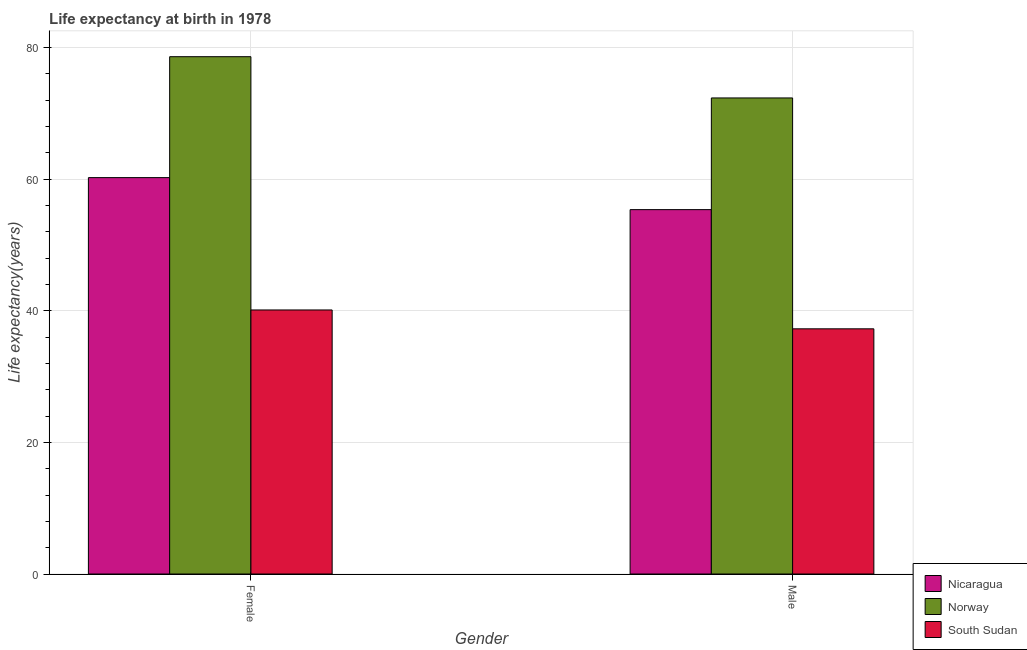How many different coloured bars are there?
Make the answer very short. 3. How many bars are there on the 2nd tick from the left?
Keep it short and to the point. 3. How many bars are there on the 1st tick from the right?
Your response must be concise. 3. What is the life expectancy(female) in South Sudan?
Make the answer very short. 40.13. Across all countries, what is the maximum life expectancy(female)?
Keep it short and to the point. 78.63. Across all countries, what is the minimum life expectancy(male)?
Keep it short and to the point. 37.27. In which country was the life expectancy(female) maximum?
Your answer should be compact. Norway. In which country was the life expectancy(male) minimum?
Your answer should be compact. South Sudan. What is the total life expectancy(female) in the graph?
Offer a terse response. 179.01. What is the difference between the life expectancy(female) in Norway and that in South Sudan?
Your answer should be very brief. 38.5. What is the difference between the life expectancy(female) in Nicaragua and the life expectancy(male) in Norway?
Your answer should be very brief. -12.11. What is the average life expectancy(male) per country?
Give a very brief answer. 55. What is the difference between the life expectancy(female) and life expectancy(male) in South Sudan?
Offer a terse response. 2.87. In how many countries, is the life expectancy(male) greater than 40 years?
Offer a terse response. 2. What is the ratio of the life expectancy(male) in South Sudan to that in Nicaragua?
Provide a succinct answer. 0.67. Is the life expectancy(male) in Nicaragua less than that in Norway?
Give a very brief answer. Yes. What does the 1st bar from the left in Male represents?
Your answer should be very brief. Nicaragua. What does the 3rd bar from the right in Male represents?
Keep it short and to the point. Nicaragua. How many bars are there?
Your response must be concise. 6. How many countries are there in the graph?
Make the answer very short. 3. What is the difference between two consecutive major ticks on the Y-axis?
Your answer should be compact. 20. Does the graph contain grids?
Ensure brevity in your answer.  Yes. What is the title of the graph?
Your answer should be compact. Life expectancy at birth in 1978. Does "Czech Republic" appear as one of the legend labels in the graph?
Your answer should be very brief. No. What is the label or title of the X-axis?
Your answer should be compact. Gender. What is the label or title of the Y-axis?
Make the answer very short. Life expectancy(years). What is the Life expectancy(years) in Nicaragua in Female?
Offer a very short reply. 60.25. What is the Life expectancy(years) in Norway in Female?
Ensure brevity in your answer.  78.63. What is the Life expectancy(years) of South Sudan in Female?
Your response must be concise. 40.13. What is the Life expectancy(years) of Nicaragua in Male?
Your answer should be very brief. 55.38. What is the Life expectancy(years) in Norway in Male?
Offer a terse response. 72.36. What is the Life expectancy(years) in South Sudan in Male?
Your response must be concise. 37.27. Across all Gender, what is the maximum Life expectancy(years) in Nicaragua?
Your answer should be very brief. 60.25. Across all Gender, what is the maximum Life expectancy(years) in Norway?
Make the answer very short. 78.63. Across all Gender, what is the maximum Life expectancy(years) in South Sudan?
Give a very brief answer. 40.13. Across all Gender, what is the minimum Life expectancy(years) in Nicaragua?
Keep it short and to the point. 55.38. Across all Gender, what is the minimum Life expectancy(years) of Norway?
Keep it short and to the point. 72.36. Across all Gender, what is the minimum Life expectancy(years) in South Sudan?
Keep it short and to the point. 37.27. What is the total Life expectancy(years) in Nicaragua in the graph?
Give a very brief answer. 115.63. What is the total Life expectancy(years) in Norway in the graph?
Keep it short and to the point. 150.99. What is the total Life expectancy(years) of South Sudan in the graph?
Provide a short and direct response. 77.4. What is the difference between the Life expectancy(years) of Nicaragua in Female and that in Male?
Give a very brief answer. 4.87. What is the difference between the Life expectancy(years) in Norway in Female and that in Male?
Your answer should be compact. 6.27. What is the difference between the Life expectancy(years) in South Sudan in Female and that in Male?
Provide a succinct answer. 2.87. What is the difference between the Life expectancy(years) of Nicaragua in Female and the Life expectancy(years) of Norway in Male?
Make the answer very short. -12.11. What is the difference between the Life expectancy(years) in Nicaragua in Female and the Life expectancy(years) in South Sudan in Male?
Provide a succinct answer. 22.98. What is the difference between the Life expectancy(years) of Norway in Female and the Life expectancy(years) of South Sudan in Male?
Offer a terse response. 41.36. What is the average Life expectancy(years) of Nicaragua per Gender?
Give a very brief answer. 57.82. What is the average Life expectancy(years) of Norway per Gender?
Make the answer very short. 75.5. What is the average Life expectancy(years) in South Sudan per Gender?
Ensure brevity in your answer.  38.7. What is the difference between the Life expectancy(years) in Nicaragua and Life expectancy(years) in Norway in Female?
Your answer should be very brief. -18.38. What is the difference between the Life expectancy(years) in Nicaragua and Life expectancy(years) in South Sudan in Female?
Provide a succinct answer. 20.12. What is the difference between the Life expectancy(years) in Norway and Life expectancy(years) in South Sudan in Female?
Give a very brief answer. 38.5. What is the difference between the Life expectancy(years) of Nicaragua and Life expectancy(years) of Norway in Male?
Keep it short and to the point. -16.98. What is the difference between the Life expectancy(years) in Nicaragua and Life expectancy(years) in South Sudan in Male?
Your answer should be very brief. 18.12. What is the difference between the Life expectancy(years) of Norway and Life expectancy(years) of South Sudan in Male?
Offer a terse response. 35.09. What is the ratio of the Life expectancy(years) in Nicaragua in Female to that in Male?
Give a very brief answer. 1.09. What is the ratio of the Life expectancy(years) of Norway in Female to that in Male?
Offer a terse response. 1.09. What is the ratio of the Life expectancy(years) in South Sudan in Female to that in Male?
Keep it short and to the point. 1.08. What is the difference between the highest and the second highest Life expectancy(years) in Nicaragua?
Make the answer very short. 4.87. What is the difference between the highest and the second highest Life expectancy(years) in Norway?
Your answer should be compact. 6.27. What is the difference between the highest and the second highest Life expectancy(years) of South Sudan?
Your answer should be very brief. 2.87. What is the difference between the highest and the lowest Life expectancy(years) of Nicaragua?
Ensure brevity in your answer.  4.87. What is the difference between the highest and the lowest Life expectancy(years) of Norway?
Make the answer very short. 6.27. What is the difference between the highest and the lowest Life expectancy(years) of South Sudan?
Provide a succinct answer. 2.87. 